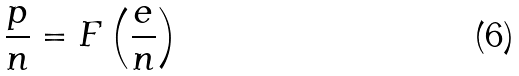Convert formula to latex. <formula><loc_0><loc_0><loc_500><loc_500>\frac { p } { n } = F \left ( \frac { e } { n } \right )</formula> 